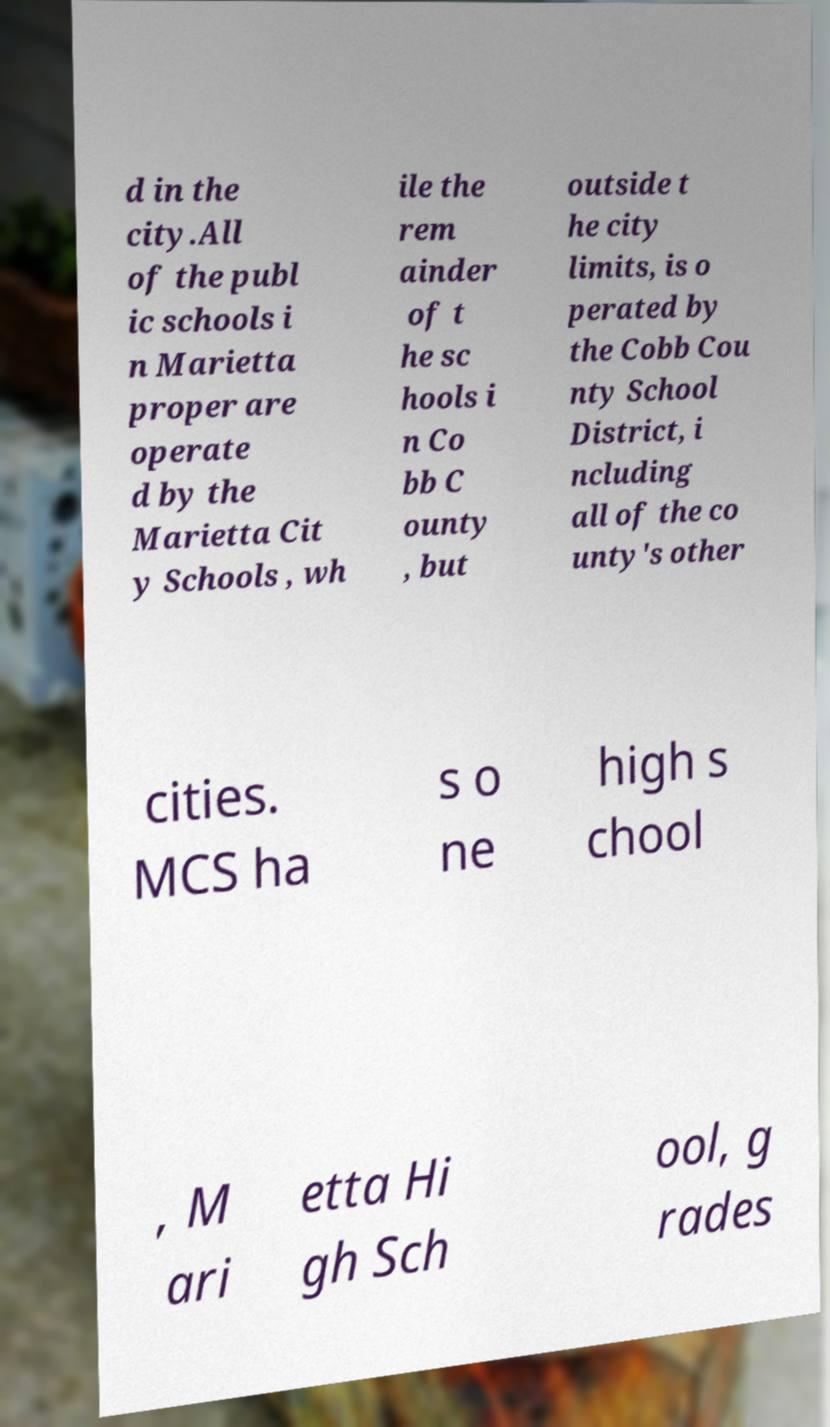Could you extract and type out the text from this image? d in the city.All of the publ ic schools i n Marietta proper are operate d by the Marietta Cit y Schools , wh ile the rem ainder of t he sc hools i n Co bb C ounty , but outside t he city limits, is o perated by the Cobb Cou nty School District, i ncluding all of the co unty's other cities. MCS ha s o ne high s chool , M ari etta Hi gh Sch ool, g rades 